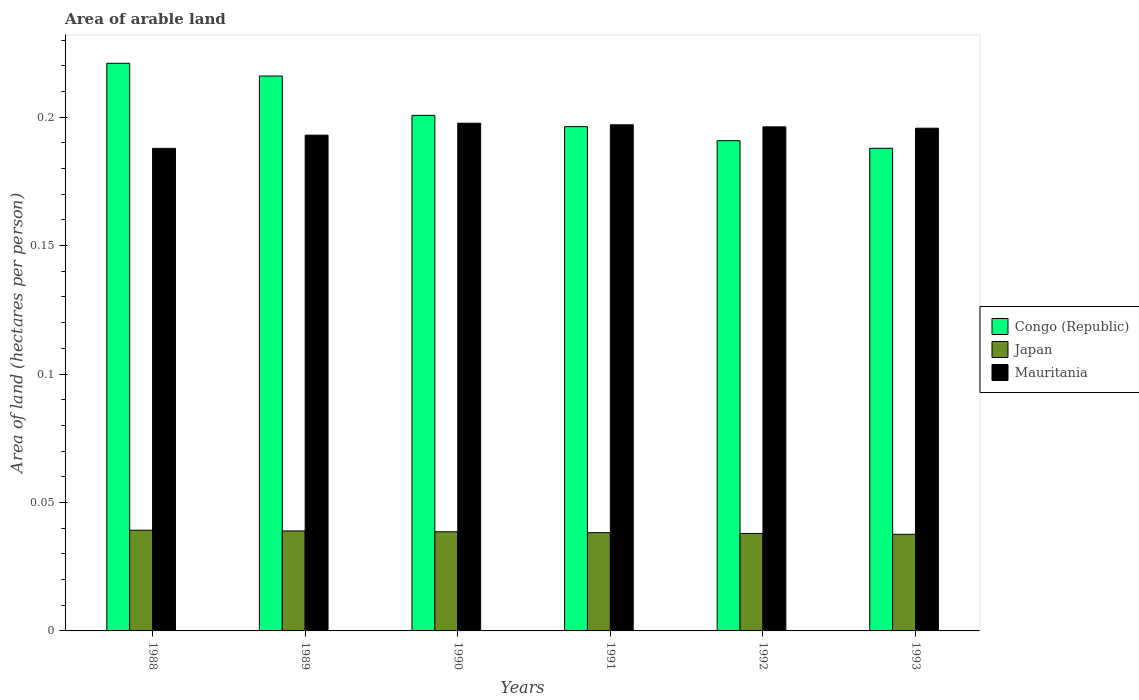How many different coloured bars are there?
Your response must be concise. 3. Are the number of bars per tick equal to the number of legend labels?
Keep it short and to the point. Yes. How many bars are there on the 5th tick from the right?
Offer a very short reply. 3. What is the total arable land in Mauritania in 1988?
Your answer should be compact. 0.19. Across all years, what is the maximum total arable land in Japan?
Provide a short and direct response. 0.04. Across all years, what is the minimum total arable land in Mauritania?
Offer a terse response. 0.19. In which year was the total arable land in Mauritania minimum?
Your answer should be very brief. 1988. What is the total total arable land in Japan in the graph?
Keep it short and to the point. 0.23. What is the difference between the total arable land in Mauritania in 1989 and that in 1993?
Your response must be concise. -0. What is the difference between the total arable land in Mauritania in 1993 and the total arable land in Congo (Republic) in 1989?
Give a very brief answer. -0.02. What is the average total arable land in Mauritania per year?
Your answer should be compact. 0.19. In the year 1988, what is the difference between the total arable land in Congo (Republic) and total arable land in Mauritania?
Give a very brief answer. 0.03. In how many years, is the total arable land in Mauritania greater than 0.04 hectares per person?
Ensure brevity in your answer.  6. What is the ratio of the total arable land in Mauritania in 1989 to that in 1990?
Make the answer very short. 0.98. Is the total arable land in Mauritania in 1988 less than that in 1989?
Your answer should be compact. Yes. Is the difference between the total arable land in Congo (Republic) in 1991 and 1993 greater than the difference between the total arable land in Mauritania in 1991 and 1993?
Ensure brevity in your answer.  Yes. What is the difference between the highest and the second highest total arable land in Japan?
Offer a very short reply. 0. What is the difference between the highest and the lowest total arable land in Japan?
Your answer should be compact. 0. What does the 1st bar from the right in 1988 represents?
Keep it short and to the point. Mauritania. How many bars are there?
Provide a succinct answer. 18. Are the values on the major ticks of Y-axis written in scientific E-notation?
Offer a terse response. No. Does the graph contain any zero values?
Your answer should be very brief. No. What is the title of the graph?
Your answer should be compact. Area of arable land. Does "Solomon Islands" appear as one of the legend labels in the graph?
Offer a very short reply. No. What is the label or title of the X-axis?
Provide a succinct answer. Years. What is the label or title of the Y-axis?
Make the answer very short. Area of land (hectares per person). What is the Area of land (hectares per person) of Congo (Republic) in 1988?
Give a very brief answer. 0.22. What is the Area of land (hectares per person) in Japan in 1988?
Your response must be concise. 0.04. What is the Area of land (hectares per person) of Mauritania in 1988?
Keep it short and to the point. 0.19. What is the Area of land (hectares per person) in Congo (Republic) in 1989?
Keep it short and to the point. 0.22. What is the Area of land (hectares per person) in Japan in 1989?
Give a very brief answer. 0.04. What is the Area of land (hectares per person) of Mauritania in 1989?
Your answer should be compact. 0.19. What is the Area of land (hectares per person) of Congo (Republic) in 1990?
Provide a short and direct response. 0.2. What is the Area of land (hectares per person) in Japan in 1990?
Provide a succinct answer. 0.04. What is the Area of land (hectares per person) in Mauritania in 1990?
Provide a succinct answer. 0.2. What is the Area of land (hectares per person) in Congo (Republic) in 1991?
Provide a short and direct response. 0.2. What is the Area of land (hectares per person) in Japan in 1991?
Provide a succinct answer. 0.04. What is the Area of land (hectares per person) of Mauritania in 1991?
Provide a succinct answer. 0.2. What is the Area of land (hectares per person) in Congo (Republic) in 1992?
Provide a short and direct response. 0.19. What is the Area of land (hectares per person) in Japan in 1992?
Your answer should be very brief. 0.04. What is the Area of land (hectares per person) in Mauritania in 1992?
Make the answer very short. 0.2. What is the Area of land (hectares per person) of Congo (Republic) in 1993?
Your response must be concise. 0.19. What is the Area of land (hectares per person) of Japan in 1993?
Offer a very short reply. 0.04. What is the Area of land (hectares per person) of Mauritania in 1993?
Keep it short and to the point. 0.2. Across all years, what is the maximum Area of land (hectares per person) of Congo (Republic)?
Offer a terse response. 0.22. Across all years, what is the maximum Area of land (hectares per person) in Japan?
Ensure brevity in your answer.  0.04. Across all years, what is the maximum Area of land (hectares per person) of Mauritania?
Your answer should be very brief. 0.2. Across all years, what is the minimum Area of land (hectares per person) in Congo (Republic)?
Your answer should be compact. 0.19. Across all years, what is the minimum Area of land (hectares per person) of Japan?
Keep it short and to the point. 0.04. Across all years, what is the minimum Area of land (hectares per person) in Mauritania?
Provide a succinct answer. 0.19. What is the total Area of land (hectares per person) in Congo (Republic) in the graph?
Provide a succinct answer. 1.21. What is the total Area of land (hectares per person) in Japan in the graph?
Your response must be concise. 0.23. What is the total Area of land (hectares per person) in Mauritania in the graph?
Your answer should be compact. 1.17. What is the difference between the Area of land (hectares per person) of Congo (Republic) in 1988 and that in 1989?
Your response must be concise. 0.01. What is the difference between the Area of land (hectares per person) in Japan in 1988 and that in 1989?
Offer a terse response. 0. What is the difference between the Area of land (hectares per person) in Mauritania in 1988 and that in 1989?
Your response must be concise. -0.01. What is the difference between the Area of land (hectares per person) of Congo (Republic) in 1988 and that in 1990?
Keep it short and to the point. 0.02. What is the difference between the Area of land (hectares per person) of Japan in 1988 and that in 1990?
Your response must be concise. 0. What is the difference between the Area of land (hectares per person) of Mauritania in 1988 and that in 1990?
Offer a very short reply. -0.01. What is the difference between the Area of land (hectares per person) of Congo (Republic) in 1988 and that in 1991?
Make the answer very short. 0.02. What is the difference between the Area of land (hectares per person) of Japan in 1988 and that in 1991?
Make the answer very short. 0. What is the difference between the Area of land (hectares per person) of Mauritania in 1988 and that in 1991?
Your answer should be compact. -0.01. What is the difference between the Area of land (hectares per person) of Congo (Republic) in 1988 and that in 1992?
Your answer should be compact. 0.03. What is the difference between the Area of land (hectares per person) in Japan in 1988 and that in 1992?
Provide a succinct answer. 0. What is the difference between the Area of land (hectares per person) of Mauritania in 1988 and that in 1992?
Provide a succinct answer. -0.01. What is the difference between the Area of land (hectares per person) of Congo (Republic) in 1988 and that in 1993?
Your answer should be compact. 0.03. What is the difference between the Area of land (hectares per person) in Japan in 1988 and that in 1993?
Provide a succinct answer. 0. What is the difference between the Area of land (hectares per person) in Mauritania in 1988 and that in 1993?
Provide a short and direct response. -0.01. What is the difference between the Area of land (hectares per person) of Congo (Republic) in 1989 and that in 1990?
Give a very brief answer. 0.02. What is the difference between the Area of land (hectares per person) in Mauritania in 1989 and that in 1990?
Keep it short and to the point. -0. What is the difference between the Area of land (hectares per person) in Congo (Republic) in 1989 and that in 1991?
Offer a terse response. 0.02. What is the difference between the Area of land (hectares per person) in Japan in 1989 and that in 1991?
Offer a very short reply. 0. What is the difference between the Area of land (hectares per person) in Mauritania in 1989 and that in 1991?
Your answer should be very brief. -0. What is the difference between the Area of land (hectares per person) of Congo (Republic) in 1989 and that in 1992?
Ensure brevity in your answer.  0.03. What is the difference between the Area of land (hectares per person) in Japan in 1989 and that in 1992?
Offer a very short reply. 0. What is the difference between the Area of land (hectares per person) of Mauritania in 1989 and that in 1992?
Offer a very short reply. -0. What is the difference between the Area of land (hectares per person) in Congo (Republic) in 1989 and that in 1993?
Your answer should be very brief. 0.03. What is the difference between the Area of land (hectares per person) in Japan in 1989 and that in 1993?
Offer a very short reply. 0. What is the difference between the Area of land (hectares per person) of Mauritania in 1989 and that in 1993?
Provide a succinct answer. -0. What is the difference between the Area of land (hectares per person) of Congo (Republic) in 1990 and that in 1991?
Provide a succinct answer. 0. What is the difference between the Area of land (hectares per person) in Mauritania in 1990 and that in 1991?
Keep it short and to the point. 0. What is the difference between the Area of land (hectares per person) in Congo (Republic) in 1990 and that in 1992?
Give a very brief answer. 0.01. What is the difference between the Area of land (hectares per person) in Japan in 1990 and that in 1992?
Provide a succinct answer. 0. What is the difference between the Area of land (hectares per person) of Mauritania in 1990 and that in 1992?
Ensure brevity in your answer.  0. What is the difference between the Area of land (hectares per person) of Congo (Republic) in 1990 and that in 1993?
Keep it short and to the point. 0.01. What is the difference between the Area of land (hectares per person) of Mauritania in 1990 and that in 1993?
Your answer should be compact. 0. What is the difference between the Area of land (hectares per person) in Congo (Republic) in 1991 and that in 1992?
Keep it short and to the point. 0.01. What is the difference between the Area of land (hectares per person) of Japan in 1991 and that in 1992?
Keep it short and to the point. 0. What is the difference between the Area of land (hectares per person) in Mauritania in 1991 and that in 1992?
Offer a very short reply. 0. What is the difference between the Area of land (hectares per person) in Congo (Republic) in 1991 and that in 1993?
Ensure brevity in your answer.  0.01. What is the difference between the Area of land (hectares per person) in Japan in 1991 and that in 1993?
Offer a terse response. 0. What is the difference between the Area of land (hectares per person) in Mauritania in 1991 and that in 1993?
Ensure brevity in your answer.  0. What is the difference between the Area of land (hectares per person) in Congo (Republic) in 1992 and that in 1993?
Provide a short and direct response. 0. What is the difference between the Area of land (hectares per person) of Congo (Republic) in 1988 and the Area of land (hectares per person) of Japan in 1989?
Your answer should be compact. 0.18. What is the difference between the Area of land (hectares per person) in Congo (Republic) in 1988 and the Area of land (hectares per person) in Mauritania in 1989?
Make the answer very short. 0.03. What is the difference between the Area of land (hectares per person) of Japan in 1988 and the Area of land (hectares per person) of Mauritania in 1989?
Provide a succinct answer. -0.15. What is the difference between the Area of land (hectares per person) in Congo (Republic) in 1988 and the Area of land (hectares per person) in Japan in 1990?
Your answer should be compact. 0.18. What is the difference between the Area of land (hectares per person) of Congo (Republic) in 1988 and the Area of land (hectares per person) of Mauritania in 1990?
Your answer should be very brief. 0.02. What is the difference between the Area of land (hectares per person) in Japan in 1988 and the Area of land (hectares per person) in Mauritania in 1990?
Offer a terse response. -0.16. What is the difference between the Area of land (hectares per person) in Congo (Republic) in 1988 and the Area of land (hectares per person) in Japan in 1991?
Make the answer very short. 0.18. What is the difference between the Area of land (hectares per person) of Congo (Republic) in 1988 and the Area of land (hectares per person) of Mauritania in 1991?
Give a very brief answer. 0.02. What is the difference between the Area of land (hectares per person) in Japan in 1988 and the Area of land (hectares per person) in Mauritania in 1991?
Provide a succinct answer. -0.16. What is the difference between the Area of land (hectares per person) of Congo (Republic) in 1988 and the Area of land (hectares per person) of Japan in 1992?
Ensure brevity in your answer.  0.18. What is the difference between the Area of land (hectares per person) of Congo (Republic) in 1988 and the Area of land (hectares per person) of Mauritania in 1992?
Your response must be concise. 0.02. What is the difference between the Area of land (hectares per person) of Japan in 1988 and the Area of land (hectares per person) of Mauritania in 1992?
Provide a short and direct response. -0.16. What is the difference between the Area of land (hectares per person) of Congo (Republic) in 1988 and the Area of land (hectares per person) of Japan in 1993?
Your answer should be very brief. 0.18. What is the difference between the Area of land (hectares per person) of Congo (Republic) in 1988 and the Area of land (hectares per person) of Mauritania in 1993?
Ensure brevity in your answer.  0.03. What is the difference between the Area of land (hectares per person) of Japan in 1988 and the Area of land (hectares per person) of Mauritania in 1993?
Your answer should be very brief. -0.16. What is the difference between the Area of land (hectares per person) of Congo (Republic) in 1989 and the Area of land (hectares per person) of Japan in 1990?
Give a very brief answer. 0.18. What is the difference between the Area of land (hectares per person) in Congo (Republic) in 1989 and the Area of land (hectares per person) in Mauritania in 1990?
Give a very brief answer. 0.02. What is the difference between the Area of land (hectares per person) of Japan in 1989 and the Area of land (hectares per person) of Mauritania in 1990?
Give a very brief answer. -0.16. What is the difference between the Area of land (hectares per person) of Congo (Republic) in 1989 and the Area of land (hectares per person) of Japan in 1991?
Provide a succinct answer. 0.18. What is the difference between the Area of land (hectares per person) of Congo (Republic) in 1989 and the Area of land (hectares per person) of Mauritania in 1991?
Offer a very short reply. 0.02. What is the difference between the Area of land (hectares per person) in Japan in 1989 and the Area of land (hectares per person) in Mauritania in 1991?
Keep it short and to the point. -0.16. What is the difference between the Area of land (hectares per person) of Congo (Republic) in 1989 and the Area of land (hectares per person) of Japan in 1992?
Provide a succinct answer. 0.18. What is the difference between the Area of land (hectares per person) of Congo (Republic) in 1989 and the Area of land (hectares per person) of Mauritania in 1992?
Provide a succinct answer. 0.02. What is the difference between the Area of land (hectares per person) of Japan in 1989 and the Area of land (hectares per person) of Mauritania in 1992?
Your response must be concise. -0.16. What is the difference between the Area of land (hectares per person) in Congo (Republic) in 1989 and the Area of land (hectares per person) in Japan in 1993?
Offer a terse response. 0.18. What is the difference between the Area of land (hectares per person) of Congo (Republic) in 1989 and the Area of land (hectares per person) of Mauritania in 1993?
Your response must be concise. 0.02. What is the difference between the Area of land (hectares per person) in Japan in 1989 and the Area of land (hectares per person) in Mauritania in 1993?
Provide a short and direct response. -0.16. What is the difference between the Area of land (hectares per person) of Congo (Republic) in 1990 and the Area of land (hectares per person) of Japan in 1991?
Give a very brief answer. 0.16. What is the difference between the Area of land (hectares per person) in Congo (Republic) in 1990 and the Area of land (hectares per person) in Mauritania in 1991?
Ensure brevity in your answer.  0. What is the difference between the Area of land (hectares per person) in Japan in 1990 and the Area of land (hectares per person) in Mauritania in 1991?
Offer a terse response. -0.16. What is the difference between the Area of land (hectares per person) of Congo (Republic) in 1990 and the Area of land (hectares per person) of Japan in 1992?
Your answer should be compact. 0.16. What is the difference between the Area of land (hectares per person) of Congo (Republic) in 1990 and the Area of land (hectares per person) of Mauritania in 1992?
Give a very brief answer. 0. What is the difference between the Area of land (hectares per person) of Japan in 1990 and the Area of land (hectares per person) of Mauritania in 1992?
Ensure brevity in your answer.  -0.16. What is the difference between the Area of land (hectares per person) in Congo (Republic) in 1990 and the Area of land (hectares per person) in Japan in 1993?
Your answer should be very brief. 0.16. What is the difference between the Area of land (hectares per person) of Congo (Republic) in 1990 and the Area of land (hectares per person) of Mauritania in 1993?
Provide a short and direct response. 0.01. What is the difference between the Area of land (hectares per person) in Japan in 1990 and the Area of land (hectares per person) in Mauritania in 1993?
Your answer should be compact. -0.16. What is the difference between the Area of land (hectares per person) in Congo (Republic) in 1991 and the Area of land (hectares per person) in Japan in 1992?
Make the answer very short. 0.16. What is the difference between the Area of land (hectares per person) of Congo (Republic) in 1991 and the Area of land (hectares per person) of Mauritania in 1992?
Give a very brief answer. 0. What is the difference between the Area of land (hectares per person) in Japan in 1991 and the Area of land (hectares per person) in Mauritania in 1992?
Keep it short and to the point. -0.16. What is the difference between the Area of land (hectares per person) in Congo (Republic) in 1991 and the Area of land (hectares per person) in Japan in 1993?
Provide a succinct answer. 0.16. What is the difference between the Area of land (hectares per person) in Congo (Republic) in 1991 and the Area of land (hectares per person) in Mauritania in 1993?
Your answer should be very brief. 0. What is the difference between the Area of land (hectares per person) of Japan in 1991 and the Area of land (hectares per person) of Mauritania in 1993?
Your answer should be very brief. -0.16. What is the difference between the Area of land (hectares per person) in Congo (Republic) in 1992 and the Area of land (hectares per person) in Japan in 1993?
Your answer should be compact. 0.15. What is the difference between the Area of land (hectares per person) in Congo (Republic) in 1992 and the Area of land (hectares per person) in Mauritania in 1993?
Ensure brevity in your answer.  -0. What is the difference between the Area of land (hectares per person) of Japan in 1992 and the Area of land (hectares per person) of Mauritania in 1993?
Your answer should be very brief. -0.16. What is the average Area of land (hectares per person) of Congo (Republic) per year?
Make the answer very short. 0.2. What is the average Area of land (hectares per person) of Japan per year?
Provide a short and direct response. 0.04. What is the average Area of land (hectares per person) of Mauritania per year?
Keep it short and to the point. 0.19. In the year 1988, what is the difference between the Area of land (hectares per person) in Congo (Republic) and Area of land (hectares per person) in Japan?
Your answer should be compact. 0.18. In the year 1988, what is the difference between the Area of land (hectares per person) in Congo (Republic) and Area of land (hectares per person) in Mauritania?
Make the answer very short. 0.03. In the year 1988, what is the difference between the Area of land (hectares per person) of Japan and Area of land (hectares per person) of Mauritania?
Your answer should be very brief. -0.15. In the year 1989, what is the difference between the Area of land (hectares per person) of Congo (Republic) and Area of land (hectares per person) of Japan?
Your answer should be compact. 0.18. In the year 1989, what is the difference between the Area of land (hectares per person) of Congo (Republic) and Area of land (hectares per person) of Mauritania?
Ensure brevity in your answer.  0.02. In the year 1989, what is the difference between the Area of land (hectares per person) of Japan and Area of land (hectares per person) of Mauritania?
Give a very brief answer. -0.15. In the year 1990, what is the difference between the Area of land (hectares per person) in Congo (Republic) and Area of land (hectares per person) in Japan?
Offer a very short reply. 0.16. In the year 1990, what is the difference between the Area of land (hectares per person) of Congo (Republic) and Area of land (hectares per person) of Mauritania?
Offer a terse response. 0. In the year 1990, what is the difference between the Area of land (hectares per person) in Japan and Area of land (hectares per person) in Mauritania?
Make the answer very short. -0.16. In the year 1991, what is the difference between the Area of land (hectares per person) in Congo (Republic) and Area of land (hectares per person) in Japan?
Offer a very short reply. 0.16. In the year 1991, what is the difference between the Area of land (hectares per person) in Congo (Republic) and Area of land (hectares per person) in Mauritania?
Your answer should be compact. -0. In the year 1991, what is the difference between the Area of land (hectares per person) of Japan and Area of land (hectares per person) of Mauritania?
Provide a short and direct response. -0.16. In the year 1992, what is the difference between the Area of land (hectares per person) of Congo (Republic) and Area of land (hectares per person) of Japan?
Offer a very short reply. 0.15. In the year 1992, what is the difference between the Area of land (hectares per person) in Congo (Republic) and Area of land (hectares per person) in Mauritania?
Your response must be concise. -0.01. In the year 1992, what is the difference between the Area of land (hectares per person) of Japan and Area of land (hectares per person) of Mauritania?
Keep it short and to the point. -0.16. In the year 1993, what is the difference between the Area of land (hectares per person) of Congo (Republic) and Area of land (hectares per person) of Japan?
Your answer should be very brief. 0.15. In the year 1993, what is the difference between the Area of land (hectares per person) of Congo (Republic) and Area of land (hectares per person) of Mauritania?
Make the answer very short. -0.01. In the year 1993, what is the difference between the Area of land (hectares per person) in Japan and Area of land (hectares per person) in Mauritania?
Provide a succinct answer. -0.16. What is the ratio of the Area of land (hectares per person) in Japan in 1988 to that in 1989?
Offer a very short reply. 1.01. What is the ratio of the Area of land (hectares per person) in Mauritania in 1988 to that in 1989?
Offer a terse response. 0.97. What is the ratio of the Area of land (hectares per person) in Congo (Republic) in 1988 to that in 1990?
Your response must be concise. 1.1. What is the ratio of the Area of land (hectares per person) of Japan in 1988 to that in 1990?
Provide a short and direct response. 1.02. What is the ratio of the Area of land (hectares per person) of Mauritania in 1988 to that in 1990?
Your answer should be very brief. 0.95. What is the ratio of the Area of land (hectares per person) of Congo (Republic) in 1988 to that in 1991?
Offer a terse response. 1.13. What is the ratio of the Area of land (hectares per person) in Japan in 1988 to that in 1991?
Ensure brevity in your answer.  1.02. What is the ratio of the Area of land (hectares per person) in Mauritania in 1988 to that in 1991?
Offer a terse response. 0.95. What is the ratio of the Area of land (hectares per person) in Congo (Republic) in 1988 to that in 1992?
Ensure brevity in your answer.  1.16. What is the ratio of the Area of land (hectares per person) in Japan in 1988 to that in 1992?
Give a very brief answer. 1.03. What is the ratio of the Area of land (hectares per person) of Mauritania in 1988 to that in 1992?
Offer a terse response. 0.96. What is the ratio of the Area of land (hectares per person) of Congo (Republic) in 1988 to that in 1993?
Offer a terse response. 1.18. What is the ratio of the Area of land (hectares per person) in Japan in 1988 to that in 1993?
Provide a short and direct response. 1.04. What is the ratio of the Area of land (hectares per person) in Mauritania in 1988 to that in 1993?
Make the answer very short. 0.96. What is the ratio of the Area of land (hectares per person) of Congo (Republic) in 1989 to that in 1990?
Provide a succinct answer. 1.08. What is the ratio of the Area of land (hectares per person) of Japan in 1989 to that in 1990?
Give a very brief answer. 1.01. What is the ratio of the Area of land (hectares per person) in Mauritania in 1989 to that in 1990?
Offer a very short reply. 0.98. What is the ratio of the Area of land (hectares per person) in Congo (Republic) in 1989 to that in 1991?
Give a very brief answer. 1.1. What is the ratio of the Area of land (hectares per person) of Japan in 1989 to that in 1991?
Your answer should be compact. 1.02. What is the ratio of the Area of land (hectares per person) in Mauritania in 1989 to that in 1991?
Make the answer very short. 0.98. What is the ratio of the Area of land (hectares per person) in Congo (Republic) in 1989 to that in 1992?
Your response must be concise. 1.13. What is the ratio of the Area of land (hectares per person) of Japan in 1989 to that in 1992?
Provide a succinct answer. 1.03. What is the ratio of the Area of land (hectares per person) of Mauritania in 1989 to that in 1992?
Offer a terse response. 0.98. What is the ratio of the Area of land (hectares per person) in Congo (Republic) in 1989 to that in 1993?
Ensure brevity in your answer.  1.15. What is the ratio of the Area of land (hectares per person) in Japan in 1989 to that in 1993?
Provide a short and direct response. 1.03. What is the ratio of the Area of land (hectares per person) in Mauritania in 1989 to that in 1993?
Offer a very short reply. 0.99. What is the ratio of the Area of land (hectares per person) in Congo (Republic) in 1990 to that in 1991?
Make the answer very short. 1.02. What is the ratio of the Area of land (hectares per person) in Congo (Republic) in 1990 to that in 1992?
Make the answer very short. 1.05. What is the ratio of the Area of land (hectares per person) in Japan in 1990 to that in 1992?
Your response must be concise. 1.02. What is the ratio of the Area of land (hectares per person) of Congo (Republic) in 1990 to that in 1993?
Ensure brevity in your answer.  1.07. What is the ratio of the Area of land (hectares per person) of Japan in 1990 to that in 1993?
Give a very brief answer. 1.03. What is the ratio of the Area of land (hectares per person) in Mauritania in 1990 to that in 1993?
Provide a short and direct response. 1.01. What is the ratio of the Area of land (hectares per person) in Congo (Republic) in 1991 to that in 1992?
Give a very brief answer. 1.03. What is the ratio of the Area of land (hectares per person) in Congo (Republic) in 1991 to that in 1993?
Your response must be concise. 1.04. What is the ratio of the Area of land (hectares per person) in Japan in 1991 to that in 1993?
Offer a very short reply. 1.02. What is the ratio of the Area of land (hectares per person) of Mauritania in 1991 to that in 1993?
Provide a succinct answer. 1.01. What is the ratio of the Area of land (hectares per person) of Congo (Republic) in 1992 to that in 1993?
Provide a short and direct response. 1.02. What is the ratio of the Area of land (hectares per person) in Japan in 1992 to that in 1993?
Provide a succinct answer. 1.01. What is the difference between the highest and the second highest Area of land (hectares per person) in Congo (Republic)?
Make the answer very short. 0.01. What is the difference between the highest and the second highest Area of land (hectares per person) in Japan?
Your response must be concise. 0. What is the difference between the highest and the second highest Area of land (hectares per person) in Mauritania?
Make the answer very short. 0. What is the difference between the highest and the lowest Area of land (hectares per person) in Congo (Republic)?
Ensure brevity in your answer.  0.03. What is the difference between the highest and the lowest Area of land (hectares per person) of Japan?
Make the answer very short. 0. What is the difference between the highest and the lowest Area of land (hectares per person) in Mauritania?
Provide a short and direct response. 0.01. 